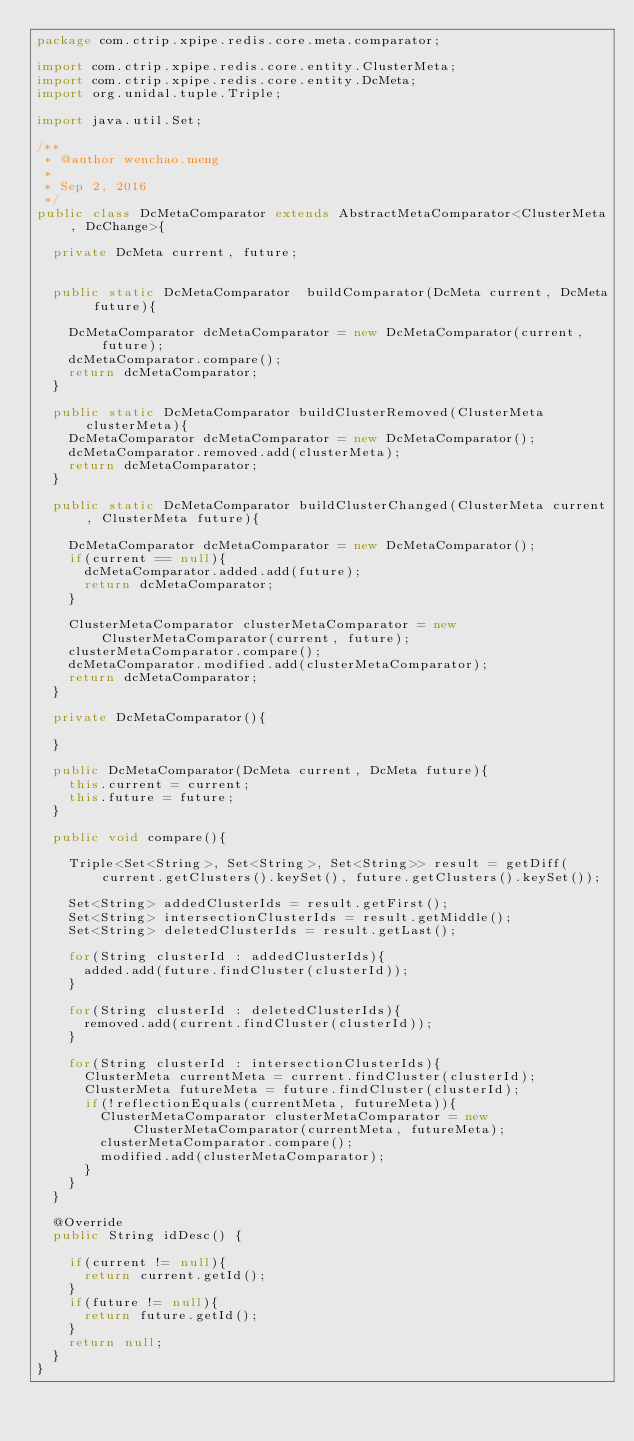<code> <loc_0><loc_0><loc_500><loc_500><_Java_>package com.ctrip.xpipe.redis.core.meta.comparator;

import com.ctrip.xpipe.redis.core.entity.ClusterMeta;
import com.ctrip.xpipe.redis.core.entity.DcMeta;
import org.unidal.tuple.Triple;

import java.util.Set;

/**
 * @author wenchao.meng
 *
 * Sep 2, 2016
 */
public class DcMetaComparator extends AbstractMetaComparator<ClusterMeta, DcChange>{
	
	private DcMeta current, future;
	
	
	public static DcMetaComparator  buildComparator(DcMeta current, DcMeta future){
		
		DcMetaComparator dcMetaComparator = new DcMetaComparator(current, future);
		dcMetaComparator.compare();
		return dcMetaComparator;
	}
	
	public static DcMetaComparator buildClusterRemoved(ClusterMeta clusterMeta){
		DcMetaComparator dcMetaComparator = new DcMetaComparator();
		dcMetaComparator.removed.add(clusterMeta);
		return dcMetaComparator;
	}

	public static DcMetaComparator buildClusterChanged(ClusterMeta current, ClusterMeta future){
		
		DcMetaComparator dcMetaComparator = new DcMetaComparator();
		if(current == null){
			dcMetaComparator.added.add(future);
			return dcMetaComparator;
		}
		
		ClusterMetaComparator clusterMetaComparator = new ClusterMetaComparator(current, future);
		clusterMetaComparator.compare();
		dcMetaComparator.modified.add(clusterMetaComparator);
		return dcMetaComparator;
	}

	private DcMetaComparator(){
		
	}
	
	public DcMetaComparator(DcMeta current, DcMeta future){
		this.current = current;
		this.future = future;
	}
	
	public void compare(){
		
		Triple<Set<String>, Set<String>, Set<String>> result = getDiff(current.getClusters().keySet(), future.getClusters().keySet());
		
		Set<String> addedClusterIds = result.getFirst(); 
		Set<String> intersectionClusterIds = result.getMiddle();
		Set<String> deletedClusterIds = result.getLast();
		
		for(String clusterId : addedClusterIds){
			added.add(future.findCluster(clusterId));
		}
		
		for(String clusterId : deletedClusterIds){
			removed.add(current.findCluster(clusterId));
		}
		
		for(String clusterId : intersectionClusterIds){
			ClusterMeta currentMeta = current.findCluster(clusterId);
			ClusterMeta futureMeta = future.findCluster(clusterId);
			if(!reflectionEquals(currentMeta, futureMeta)){
				ClusterMetaComparator clusterMetaComparator = new ClusterMetaComparator(currentMeta, futureMeta);
				clusterMetaComparator.compare();
				modified.add(clusterMetaComparator);
			}
		}
	}

	@Override
	public String idDesc() {

		if(current != null){
			return current.getId();
		}
		if(future != null){
			return future.getId();
		}
		return null;
	}
}
</code> 